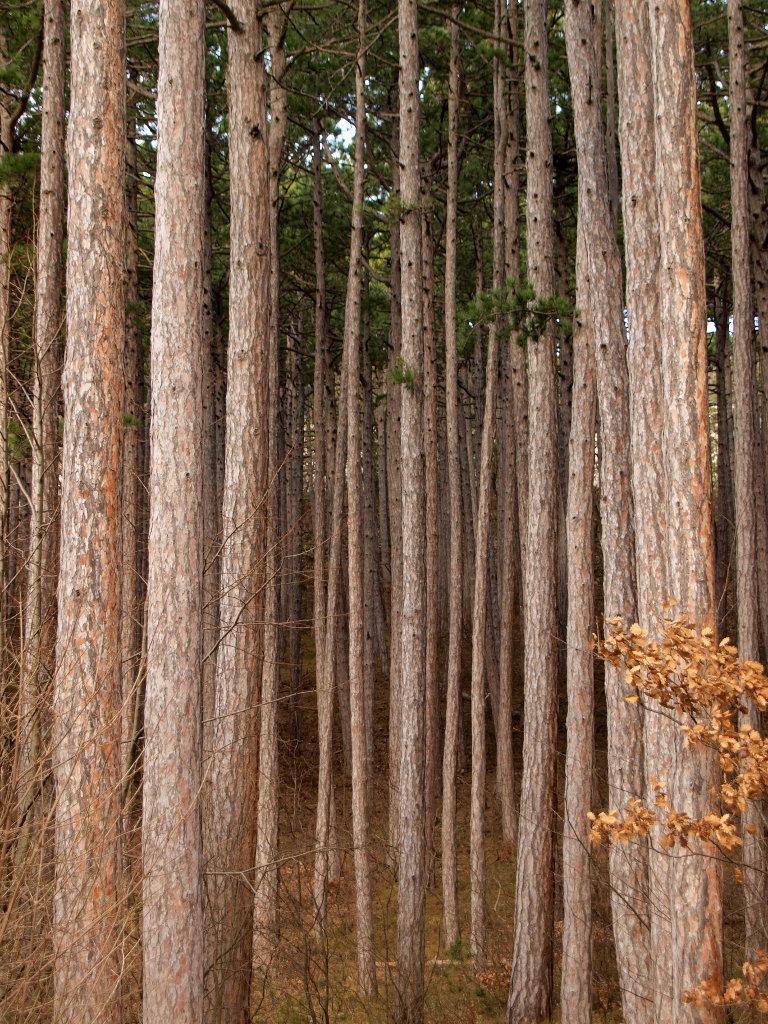How would you summarize this image in a sentence or two? In the image we can see there are many trees, leaves and the white sky. 